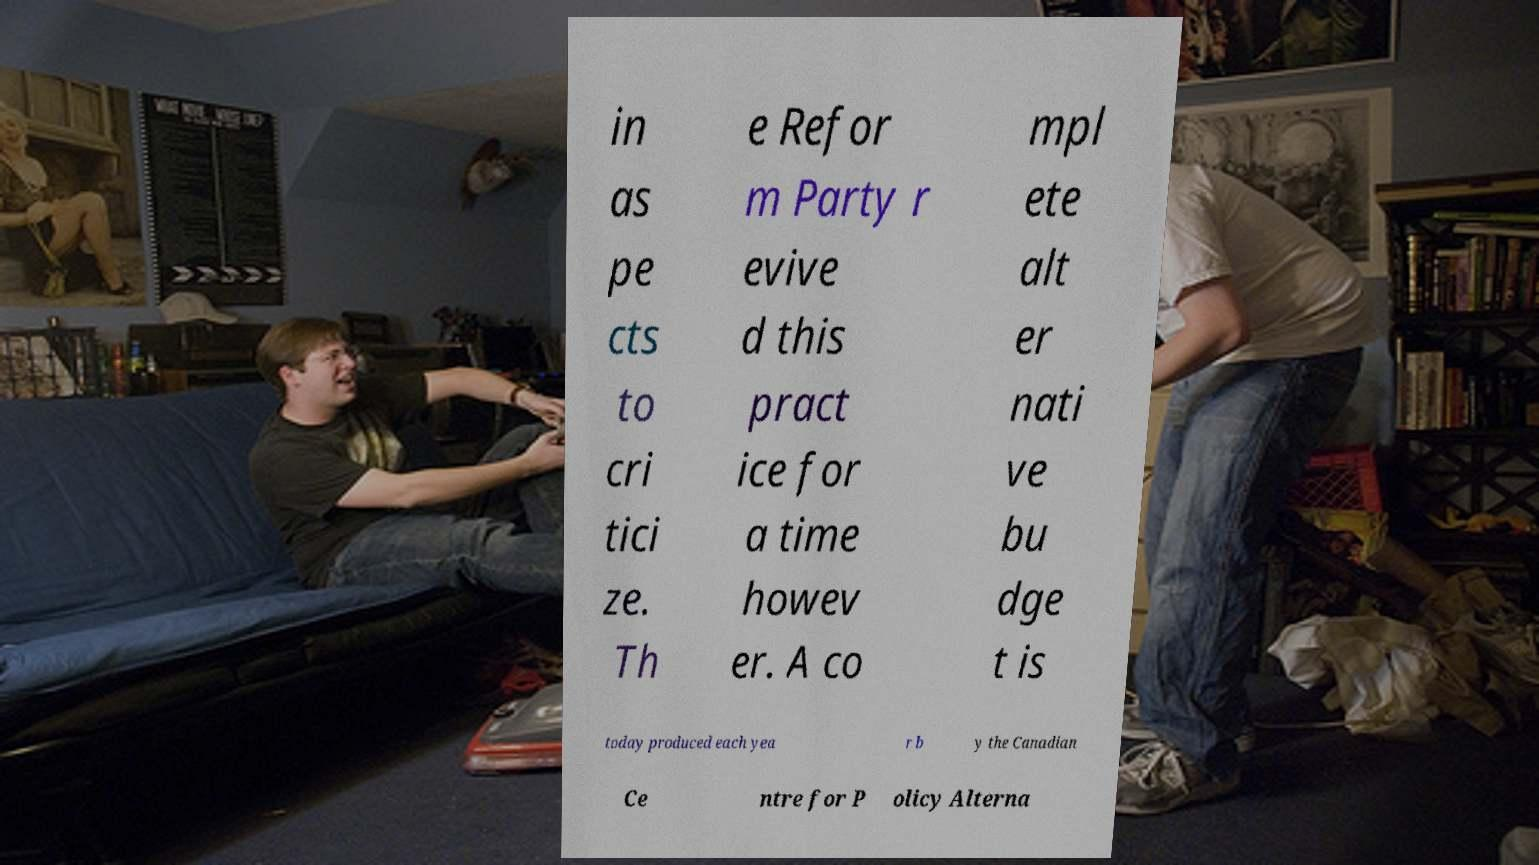I need the written content from this picture converted into text. Can you do that? in as pe cts to cri tici ze. Th e Refor m Party r evive d this pract ice for a time howev er. A co mpl ete alt er nati ve bu dge t is today produced each yea r b y the Canadian Ce ntre for P olicy Alterna 